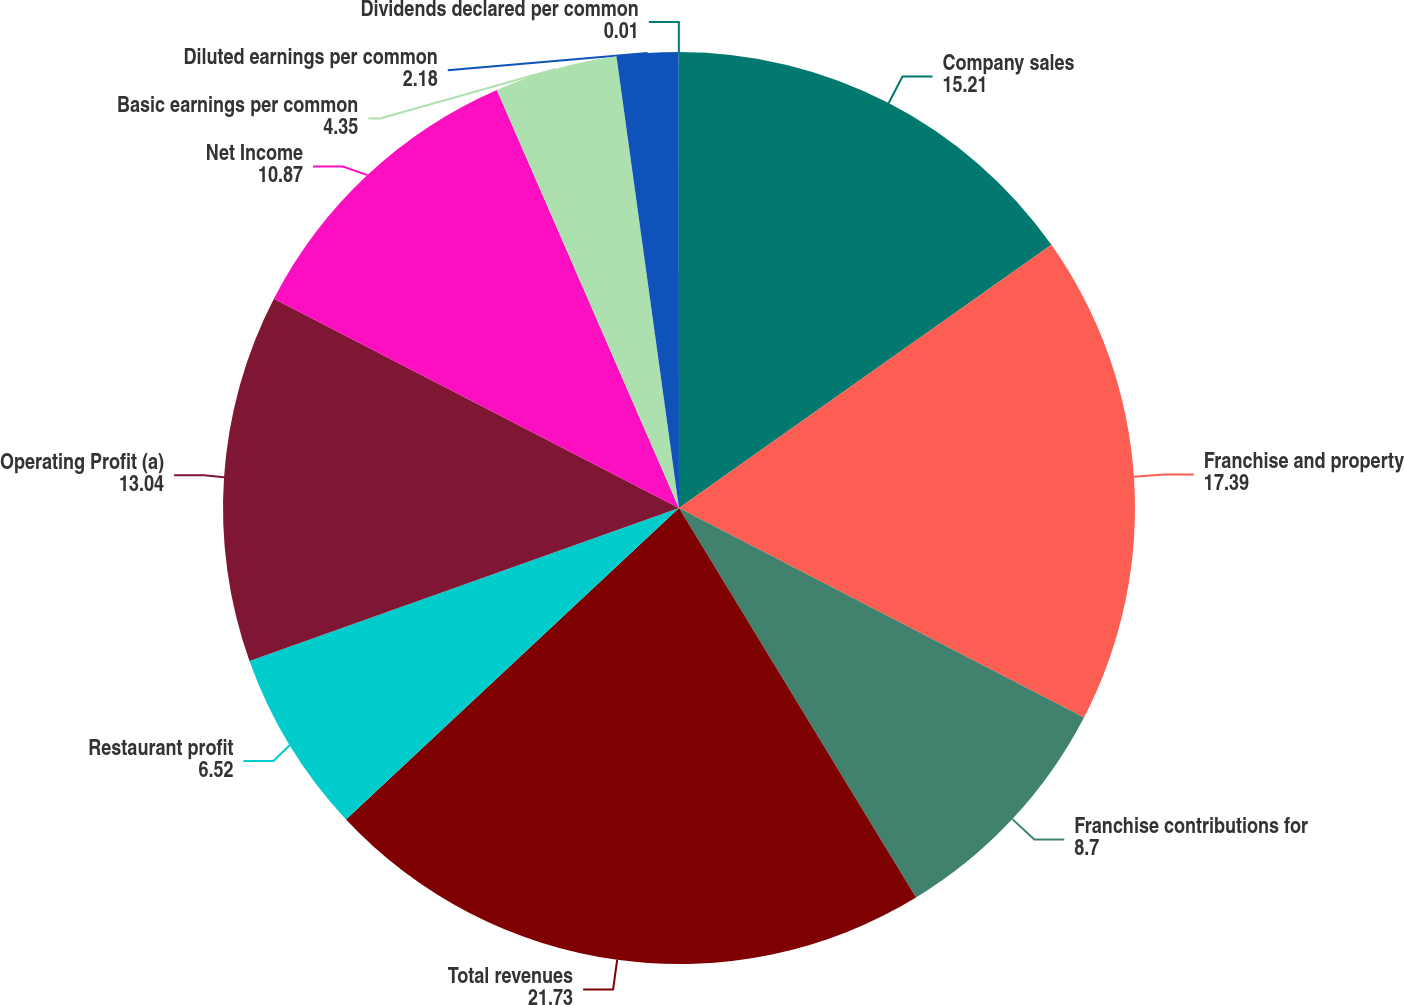Convert chart. <chart><loc_0><loc_0><loc_500><loc_500><pie_chart><fcel>Company sales<fcel>Franchise and property<fcel>Franchise contributions for<fcel>Total revenues<fcel>Restaurant profit<fcel>Operating Profit (a)<fcel>Net Income<fcel>Basic earnings per common<fcel>Diluted earnings per common<fcel>Dividends declared per common<nl><fcel>15.21%<fcel>17.39%<fcel>8.7%<fcel>21.73%<fcel>6.52%<fcel>13.04%<fcel>10.87%<fcel>4.35%<fcel>2.18%<fcel>0.01%<nl></chart> 